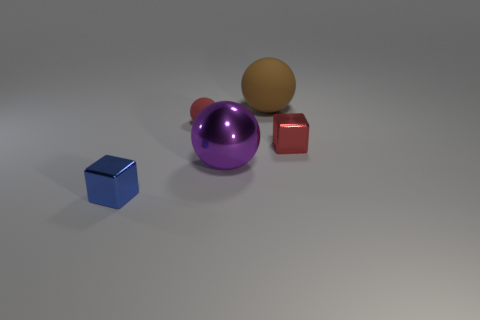Add 3 cyan metallic spheres. How many objects exist? 8 Subtract all balls. How many objects are left? 2 Subtract 1 purple balls. How many objects are left? 4 Subtract all small matte spheres. Subtract all small red metallic objects. How many objects are left? 3 Add 4 big purple shiny spheres. How many big purple shiny spheres are left? 5 Add 2 matte cubes. How many matte cubes exist? 2 